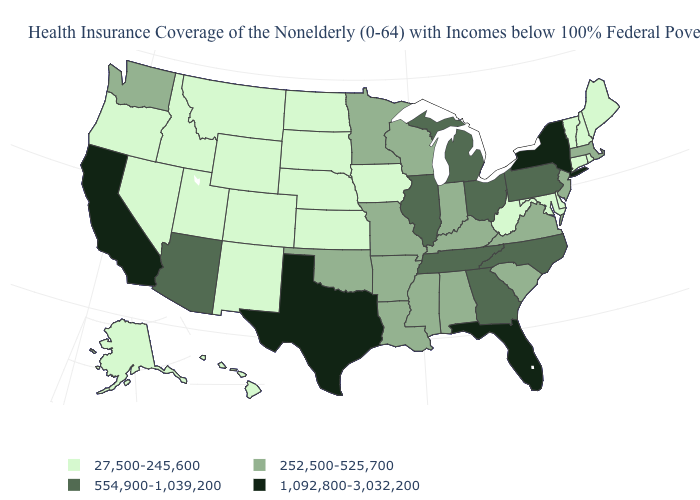Among the states that border Illinois , which have the lowest value?
Write a very short answer. Iowa. Does West Virginia have a lower value than Kentucky?
Concise answer only. Yes. What is the value of Illinois?
Quick response, please. 554,900-1,039,200. Name the states that have a value in the range 1,092,800-3,032,200?
Quick response, please. California, Florida, New York, Texas. Name the states that have a value in the range 27,500-245,600?
Give a very brief answer. Alaska, Colorado, Connecticut, Delaware, Hawaii, Idaho, Iowa, Kansas, Maine, Maryland, Montana, Nebraska, Nevada, New Hampshire, New Mexico, North Dakota, Oregon, Rhode Island, South Dakota, Utah, Vermont, West Virginia, Wyoming. Which states have the lowest value in the USA?
Concise answer only. Alaska, Colorado, Connecticut, Delaware, Hawaii, Idaho, Iowa, Kansas, Maine, Maryland, Montana, Nebraska, Nevada, New Hampshire, New Mexico, North Dakota, Oregon, Rhode Island, South Dakota, Utah, Vermont, West Virginia, Wyoming. Name the states that have a value in the range 27,500-245,600?
Keep it brief. Alaska, Colorado, Connecticut, Delaware, Hawaii, Idaho, Iowa, Kansas, Maine, Maryland, Montana, Nebraska, Nevada, New Hampshire, New Mexico, North Dakota, Oregon, Rhode Island, South Dakota, Utah, Vermont, West Virginia, Wyoming. What is the value of Louisiana?
Write a very short answer. 252,500-525,700. What is the value of Alabama?
Write a very short answer. 252,500-525,700. Name the states that have a value in the range 27,500-245,600?
Short answer required. Alaska, Colorado, Connecticut, Delaware, Hawaii, Idaho, Iowa, Kansas, Maine, Maryland, Montana, Nebraska, Nevada, New Hampshire, New Mexico, North Dakota, Oregon, Rhode Island, South Dakota, Utah, Vermont, West Virginia, Wyoming. Is the legend a continuous bar?
Concise answer only. No. Name the states that have a value in the range 252,500-525,700?
Short answer required. Alabama, Arkansas, Indiana, Kentucky, Louisiana, Massachusetts, Minnesota, Mississippi, Missouri, New Jersey, Oklahoma, South Carolina, Virginia, Washington, Wisconsin. Name the states that have a value in the range 252,500-525,700?
Short answer required. Alabama, Arkansas, Indiana, Kentucky, Louisiana, Massachusetts, Minnesota, Mississippi, Missouri, New Jersey, Oklahoma, South Carolina, Virginia, Washington, Wisconsin. Does Missouri have a higher value than Kansas?
Answer briefly. Yes. What is the highest value in states that border Washington?
Write a very short answer. 27,500-245,600. 